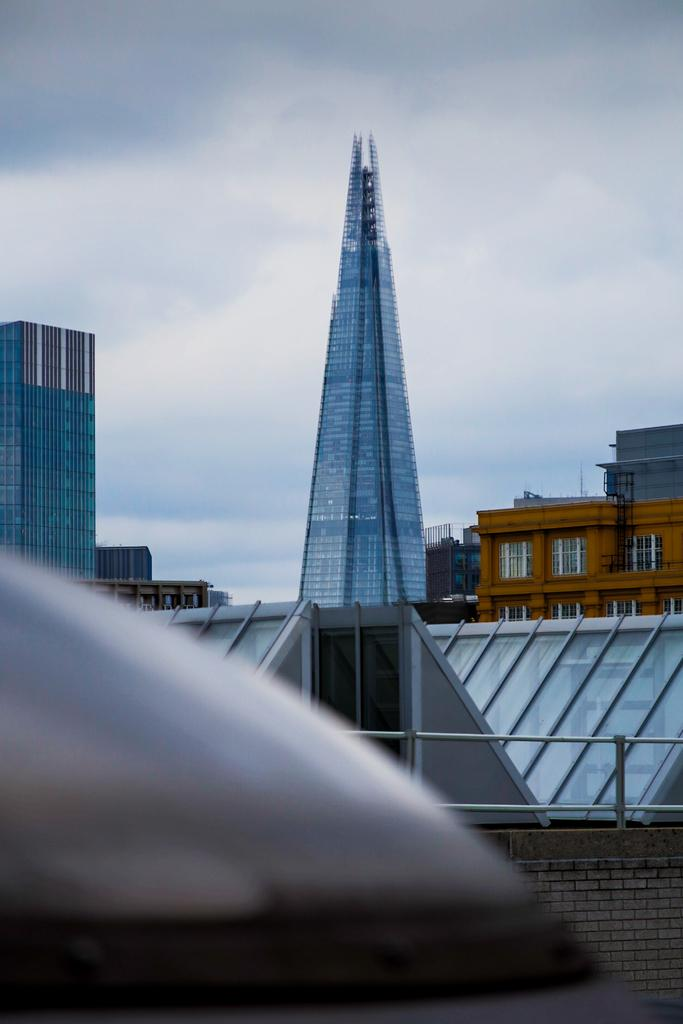What type of structures can be seen in the image? There are buildings in the image. What is located in the foreground of the image? There is a railing on a wall in the foreground. What is visible at the top of the image? The sky is visible at the top of the image. What can be seen in the sky? There are clouds in the sky. What color is the sweater worn by the nerve in the image? There is no sweater or nerve present in the image. 